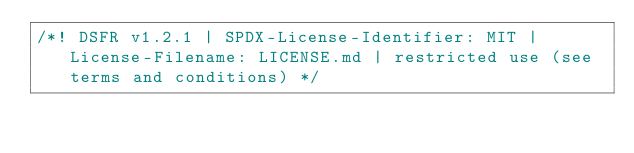<code> <loc_0><loc_0><loc_500><loc_500><_JavaScript_>/*! DSFR v1.2.1 | SPDX-License-Identifier: MIT | License-Filename: LICENSE.md | restricted use (see terms and conditions) */</code> 